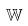<formula> <loc_0><loc_0><loc_500><loc_500>\mathbb { W }</formula> 